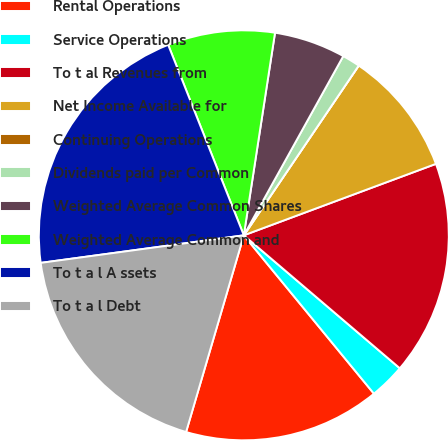Convert chart. <chart><loc_0><loc_0><loc_500><loc_500><pie_chart><fcel>Rental Operations<fcel>Service Operations<fcel>To t al Revenues from<fcel>Net Income Available for<fcel>Continuing Operations<fcel>Dividends paid per Common<fcel>Weighted Average Common Shares<fcel>Weighted Average Common and<fcel>To t a l A ssets<fcel>To t a l Debt<nl><fcel>15.49%<fcel>2.82%<fcel>16.9%<fcel>9.86%<fcel>0.0%<fcel>1.41%<fcel>5.63%<fcel>8.45%<fcel>21.13%<fcel>18.31%<nl></chart> 